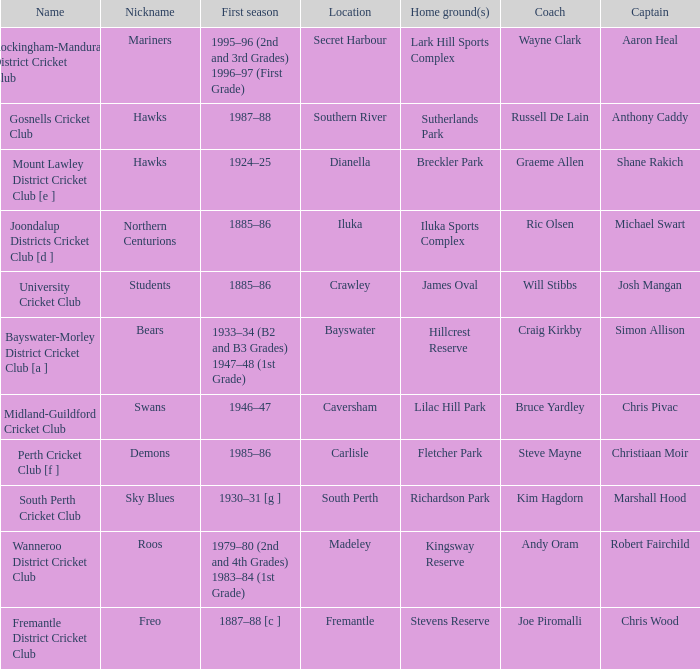For location Caversham, what is the name of the captain? Chris Pivac. 